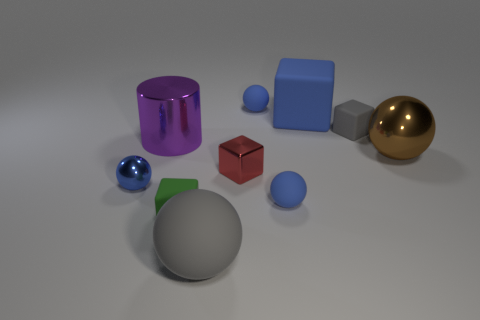Are there an equal number of purple metallic things right of the small red shiny object and small red objects?
Give a very brief answer. No. What is the color of the metallic block?
Ensure brevity in your answer.  Red. The red object that is the same material as the cylinder is what size?
Your answer should be very brief. Small. What color is the block that is the same material as the purple cylinder?
Your answer should be very brief. Red. Is there another green rubber cube of the same size as the green block?
Your answer should be compact. No. What material is the large brown object that is the same shape as the big gray object?
Keep it short and to the point. Metal. There is a gray matte object that is the same size as the green matte cube; what is its shape?
Offer a very short reply. Cube. Is there another tiny blue thing that has the same shape as the blue metal object?
Your answer should be very brief. Yes. What shape is the gray object that is on the right side of the small rubber sphere behind the tiny gray matte thing?
Your answer should be very brief. Cube. What shape is the big gray object?
Your response must be concise. Sphere. 